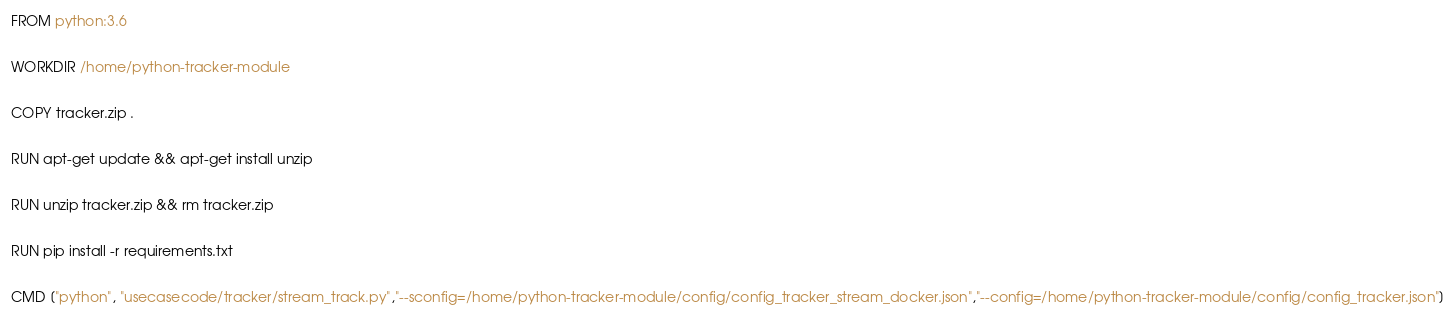Convert code to text. <code><loc_0><loc_0><loc_500><loc_500><_Dockerfile_>FROM python:3.6

WORKDIR /home/python-tracker-module

COPY tracker.zip .

RUN apt-get update && apt-get install unzip

RUN unzip tracker.zip && rm tracker.zip

RUN pip install -r requirements.txt

CMD ["python", "usecasecode/tracker/stream_track.py","--sconfig=/home/python-tracker-module/config/config_tracker_stream_docker.json","--config=/home/python-tracker-module/config/config_tracker.json"]
</code> 